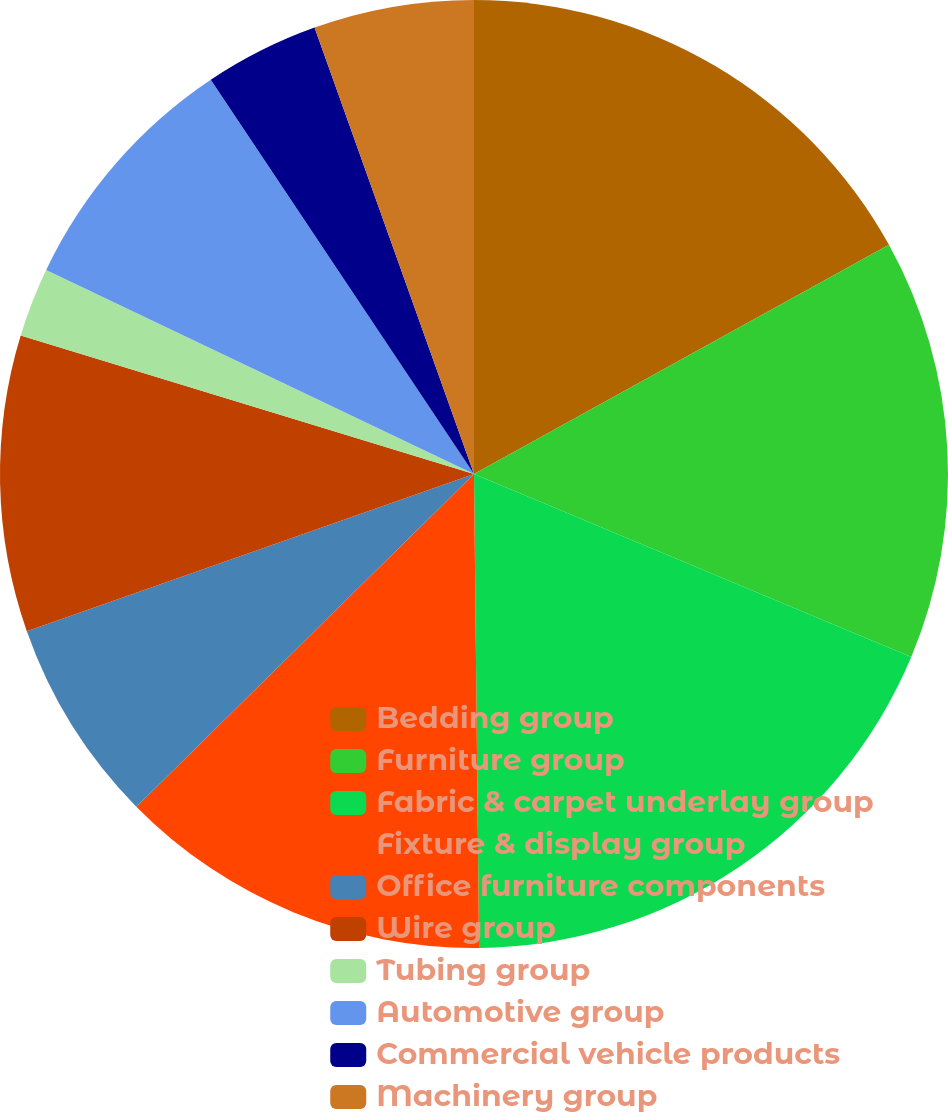Convert chart. <chart><loc_0><loc_0><loc_500><loc_500><pie_chart><fcel>Bedding group<fcel>Furniture group<fcel>Fabric & carpet underlay group<fcel>Fixture & display group<fcel>Office furniture components<fcel>Wire group<fcel>Tubing group<fcel>Automotive group<fcel>Commercial vehicle products<fcel>Machinery group<nl><fcel>16.97%<fcel>14.34%<fcel>18.52%<fcel>12.79%<fcel>7.0%<fcel>10.1%<fcel>2.36%<fcel>8.55%<fcel>3.91%<fcel>5.46%<nl></chart> 